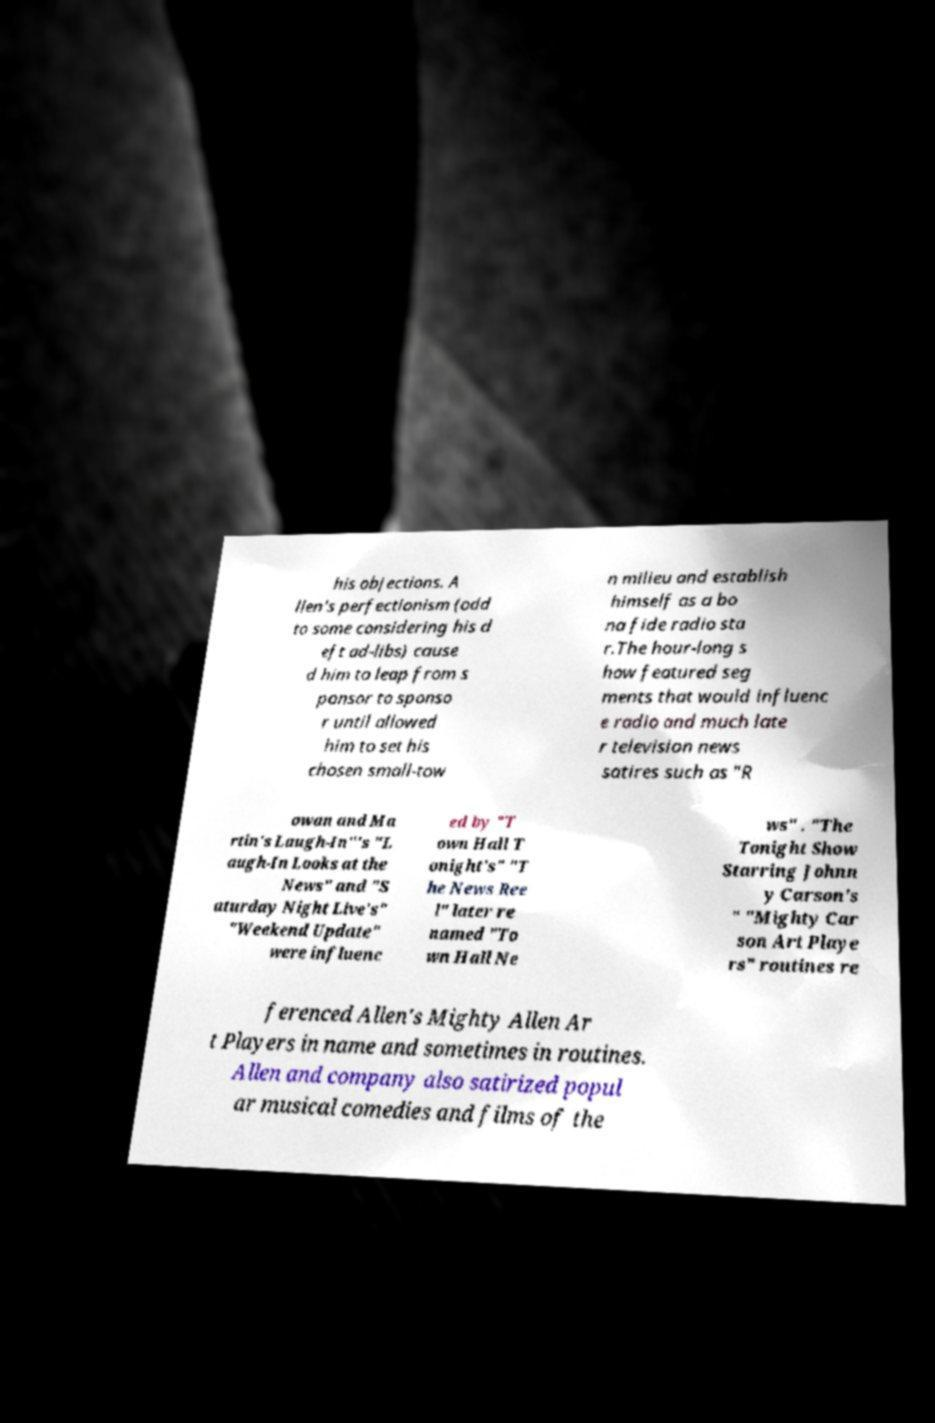For documentation purposes, I need the text within this image transcribed. Could you provide that? his objections. A llen's perfectionism (odd to some considering his d eft ad-libs) cause d him to leap from s ponsor to sponso r until allowed him to set his chosen small-tow n milieu and establish himself as a bo na fide radio sta r.The hour-long s how featured seg ments that would influenc e radio and much late r television news satires such as "R owan and Ma rtin's Laugh-In"'s "L augh-In Looks at the News" and "S aturday Night Live's" "Weekend Update" were influenc ed by "T own Hall T onight's" "T he News Ree l" later re named "To wn Hall Ne ws" . "The Tonight Show Starring Johnn y Carson's " "Mighty Car son Art Playe rs" routines re ferenced Allen's Mighty Allen Ar t Players in name and sometimes in routines. Allen and company also satirized popul ar musical comedies and films of the 